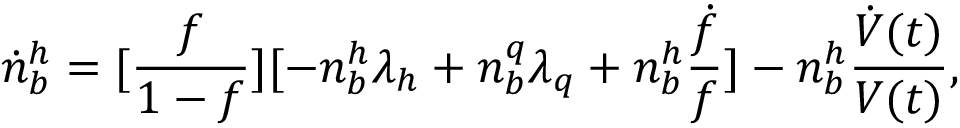<formula> <loc_0><loc_0><loc_500><loc_500>\dot { n } _ { b } ^ { h } = [ { \frac { f } { 1 - f } } ] [ - n _ { b } ^ { h } \lambda _ { h } + n _ { b } ^ { q } \lambda _ { q } + n _ { b } ^ { h } { \frac { \dot { f } } { f } } ] - n _ { b } ^ { h } { \frac { \dot { V } ( t ) } { V ( t ) } } ,</formula> 